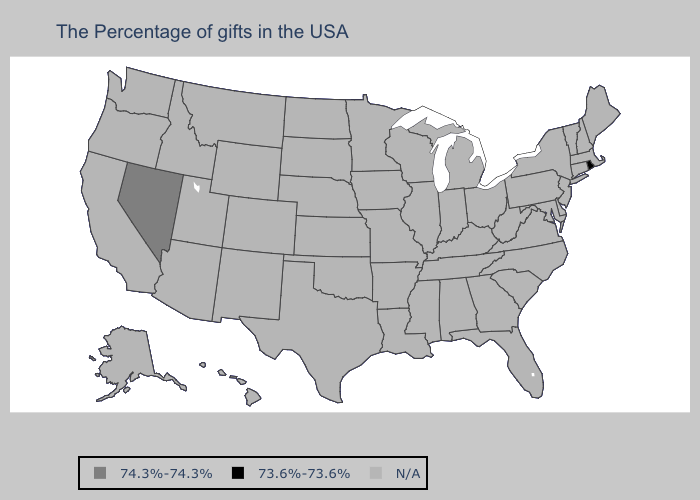Name the states that have a value in the range 74.3%-74.3%?
Short answer required. Nevada. Which states have the highest value in the USA?
Short answer required. Nevada. Name the states that have a value in the range N/A?
Short answer required. Maine, Massachusetts, New Hampshire, Vermont, Connecticut, New York, New Jersey, Delaware, Maryland, Pennsylvania, Virginia, North Carolina, South Carolina, West Virginia, Ohio, Florida, Georgia, Michigan, Kentucky, Indiana, Alabama, Tennessee, Wisconsin, Illinois, Mississippi, Louisiana, Missouri, Arkansas, Minnesota, Iowa, Kansas, Nebraska, Oklahoma, Texas, South Dakota, North Dakota, Wyoming, Colorado, New Mexico, Utah, Montana, Arizona, Idaho, California, Washington, Oregon, Alaska, Hawaii. What is the value of South Carolina?
Short answer required. N/A. Name the states that have a value in the range N/A?
Be succinct. Maine, Massachusetts, New Hampshire, Vermont, Connecticut, New York, New Jersey, Delaware, Maryland, Pennsylvania, Virginia, North Carolina, South Carolina, West Virginia, Ohio, Florida, Georgia, Michigan, Kentucky, Indiana, Alabama, Tennessee, Wisconsin, Illinois, Mississippi, Louisiana, Missouri, Arkansas, Minnesota, Iowa, Kansas, Nebraska, Oklahoma, Texas, South Dakota, North Dakota, Wyoming, Colorado, New Mexico, Utah, Montana, Arizona, Idaho, California, Washington, Oregon, Alaska, Hawaii. Which states have the lowest value in the USA?
Keep it brief. Rhode Island. What is the highest value in the Northeast ?
Be succinct. 73.6%-73.6%. Name the states that have a value in the range N/A?
Be succinct. Maine, Massachusetts, New Hampshire, Vermont, Connecticut, New York, New Jersey, Delaware, Maryland, Pennsylvania, Virginia, North Carolina, South Carolina, West Virginia, Ohio, Florida, Georgia, Michigan, Kentucky, Indiana, Alabama, Tennessee, Wisconsin, Illinois, Mississippi, Louisiana, Missouri, Arkansas, Minnesota, Iowa, Kansas, Nebraska, Oklahoma, Texas, South Dakota, North Dakota, Wyoming, Colorado, New Mexico, Utah, Montana, Arizona, Idaho, California, Washington, Oregon, Alaska, Hawaii. 